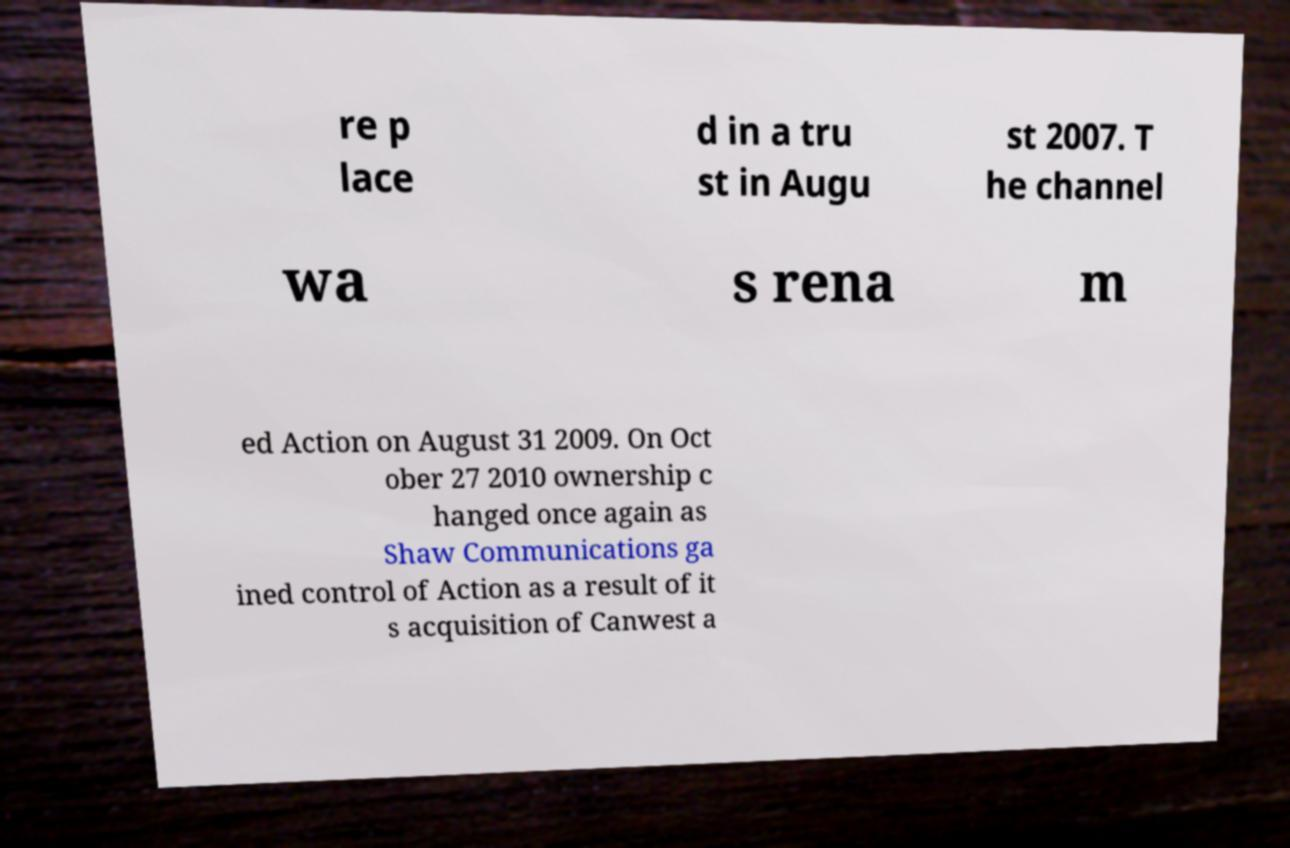Could you assist in decoding the text presented in this image and type it out clearly? re p lace d in a tru st in Augu st 2007. T he channel wa s rena m ed Action on August 31 2009. On Oct ober 27 2010 ownership c hanged once again as Shaw Communications ga ined control of Action as a result of it s acquisition of Canwest a 